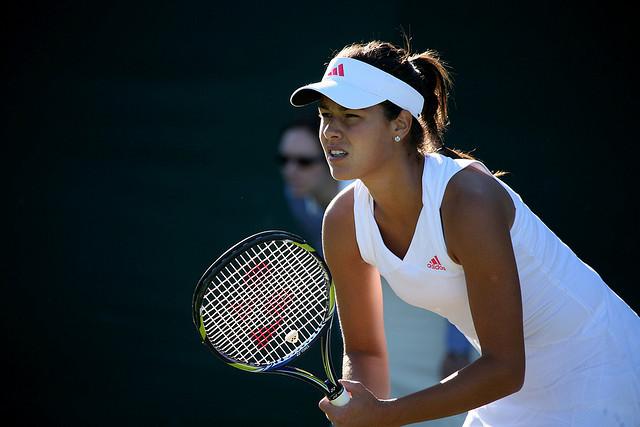What kind of jewelry is the girl wearing?
Keep it brief. Earrings. What logo is on the person's clothes?
Concise answer only. Adidas. What color is the woman's skirt?
Write a very short answer. White. Is the player sweating?
Be succinct. No. How many hands is the player using to hold the racket?
Concise answer only. 2. Is it a hot day?
Concise answer only. Yes. 